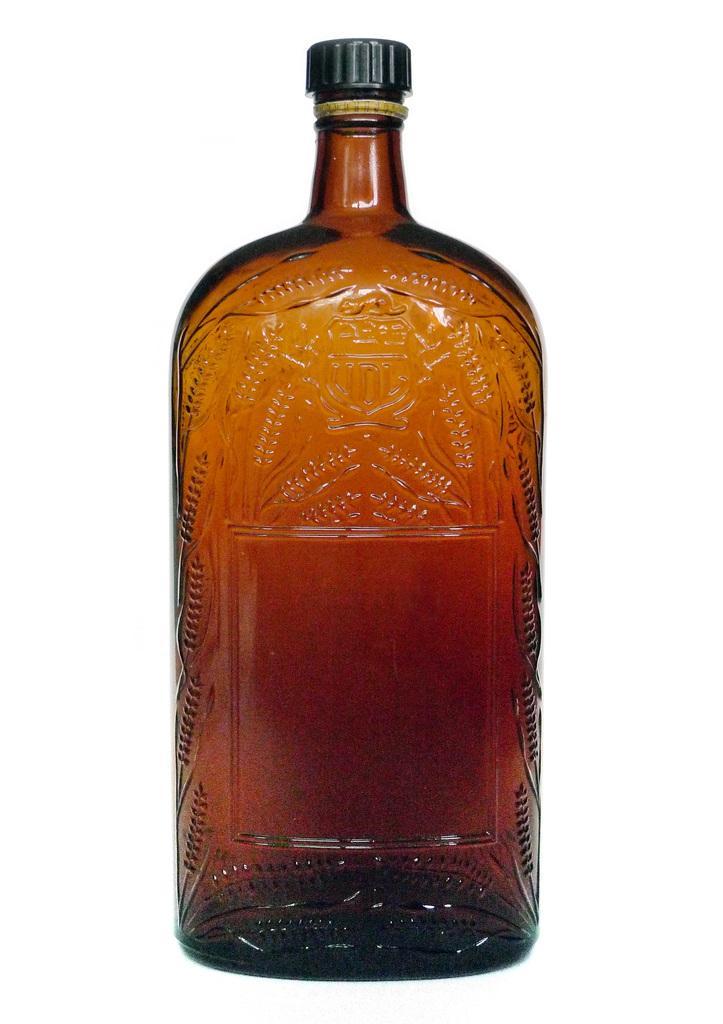Can you describe this image briefly? This bottle is highlighted in this picture. It has a black cap. 